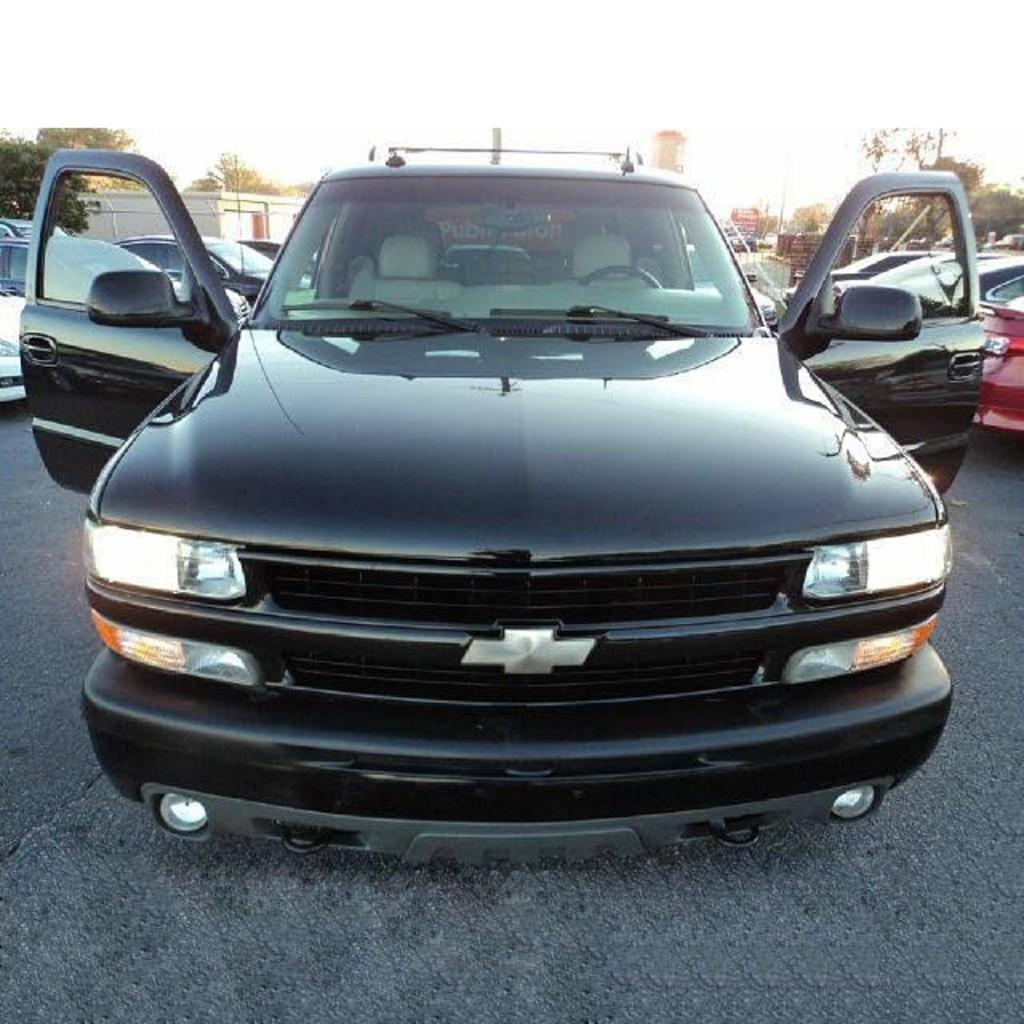What types of objects are present in the image? There are vehicles in the image. What can be seen in the background of the image? There are trees, a wall, and the sky visible in the background of the image. What type of rod is being used to measure the height of the trees in the image? There is no rod or measurement activity present in the image; it only features vehicles, trees, a wall, and the sky. 